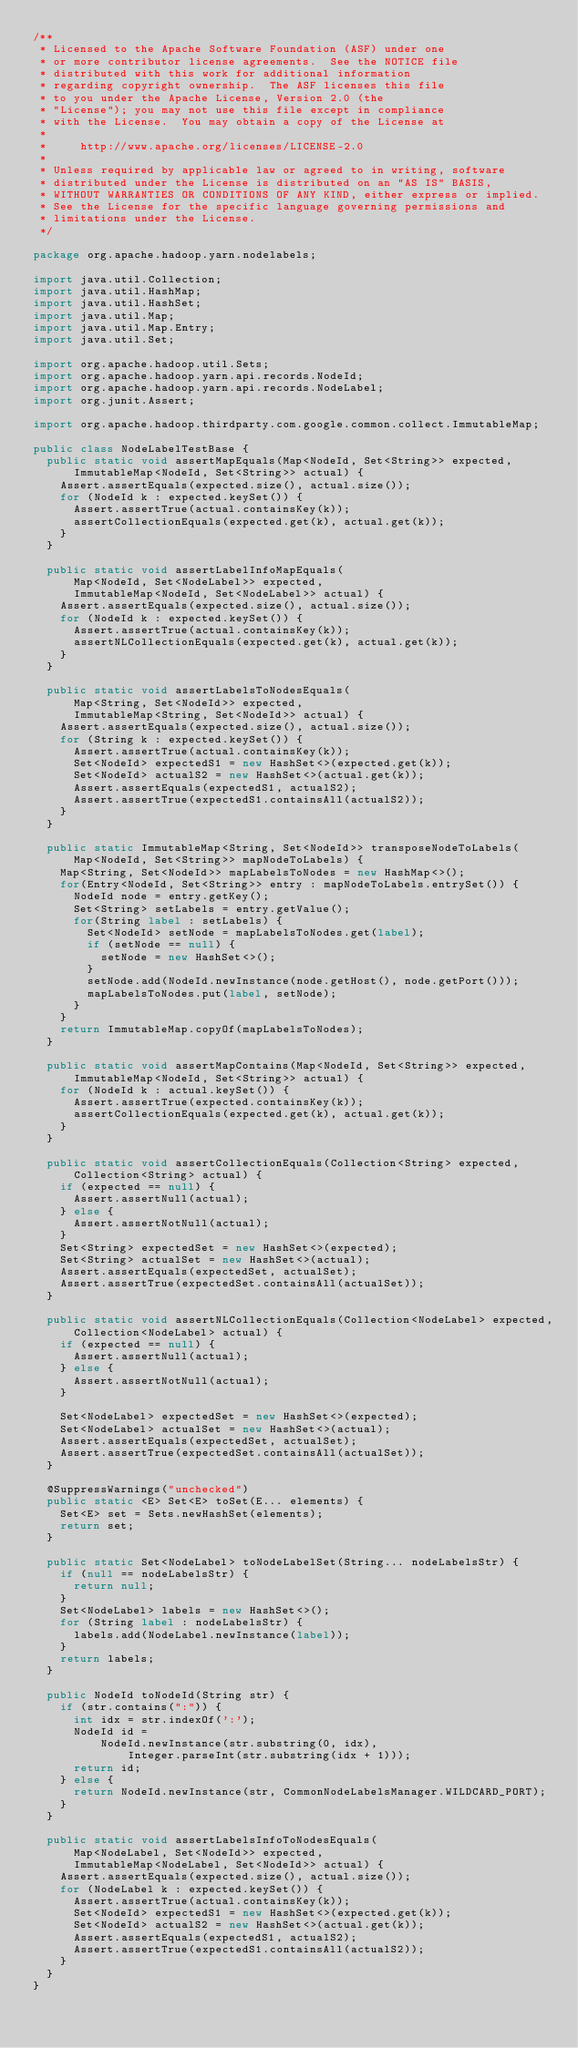Convert code to text. <code><loc_0><loc_0><loc_500><loc_500><_Java_>/**
 * Licensed to the Apache Software Foundation (ASF) under one
 * or more contributor license agreements.  See the NOTICE file
 * distributed with this work for additional information
 * regarding copyright ownership.  The ASF licenses this file
 * to you under the Apache License, Version 2.0 (the
 * "License"); you may not use this file except in compliance
 * with the License.  You may obtain a copy of the License at
 *
 *     http://www.apache.org/licenses/LICENSE-2.0
 *
 * Unless required by applicable law or agreed to in writing, software
 * distributed under the License is distributed on an "AS IS" BASIS,
 * WITHOUT WARRANTIES OR CONDITIONS OF ANY KIND, either express or implied.
 * See the License for the specific language governing permissions and
 * limitations under the License.
 */

package org.apache.hadoop.yarn.nodelabels;

import java.util.Collection;
import java.util.HashMap;
import java.util.HashSet;
import java.util.Map;
import java.util.Map.Entry;
import java.util.Set;

import org.apache.hadoop.util.Sets;
import org.apache.hadoop.yarn.api.records.NodeId;
import org.apache.hadoop.yarn.api.records.NodeLabel;
import org.junit.Assert;

import org.apache.hadoop.thirdparty.com.google.common.collect.ImmutableMap;

public class NodeLabelTestBase {
  public static void assertMapEquals(Map<NodeId, Set<String>> expected,
      ImmutableMap<NodeId, Set<String>> actual) {
    Assert.assertEquals(expected.size(), actual.size());
    for (NodeId k : expected.keySet()) {
      Assert.assertTrue(actual.containsKey(k));
      assertCollectionEquals(expected.get(k), actual.get(k));
    }
  }

  public static void assertLabelInfoMapEquals(
      Map<NodeId, Set<NodeLabel>> expected,
      ImmutableMap<NodeId, Set<NodeLabel>> actual) {
    Assert.assertEquals(expected.size(), actual.size());
    for (NodeId k : expected.keySet()) {
      Assert.assertTrue(actual.containsKey(k));
      assertNLCollectionEquals(expected.get(k), actual.get(k));
    }
  }

  public static void assertLabelsToNodesEquals(
      Map<String, Set<NodeId>> expected,
      ImmutableMap<String, Set<NodeId>> actual) {
    Assert.assertEquals(expected.size(), actual.size());
    for (String k : expected.keySet()) {
      Assert.assertTrue(actual.containsKey(k));
      Set<NodeId> expectedS1 = new HashSet<>(expected.get(k));
      Set<NodeId> actualS2 = new HashSet<>(actual.get(k));
      Assert.assertEquals(expectedS1, actualS2);
      Assert.assertTrue(expectedS1.containsAll(actualS2));
    }
  }

  public static ImmutableMap<String, Set<NodeId>> transposeNodeToLabels(
      Map<NodeId, Set<String>> mapNodeToLabels) {
    Map<String, Set<NodeId>> mapLabelsToNodes = new HashMap<>();
    for(Entry<NodeId, Set<String>> entry : mapNodeToLabels.entrySet()) {
      NodeId node = entry.getKey();
      Set<String> setLabels = entry.getValue();
      for(String label : setLabels) {
        Set<NodeId> setNode = mapLabelsToNodes.get(label);
        if (setNode == null) {
          setNode = new HashSet<>();
        }
        setNode.add(NodeId.newInstance(node.getHost(), node.getPort()));
        mapLabelsToNodes.put(label, setNode);
      }
    }
    return ImmutableMap.copyOf(mapLabelsToNodes);
  }

  public static void assertMapContains(Map<NodeId, Set<String>> expected,
      ImmutableMap<NodeId, Set<String>> actual) {
    for (NodeId k : actual.keySet()) {
      Assert.assertTrue(expected.containsKey(k));
      assertCollectionEquals(expected.get(k), actual.get(k));
    }
  }

  public static void assertCollectionEquals(Collection<String> expected,
      Collection<String> actual) {
    if (expected == null) {
      Assert.assertNull(actual);
    } else {
      Assert.assertNotNull(actual);
    }
    Set<String> expectedSet = new HashSet<>(expected);
    Set<String> actualSet = new HashSet<>(actual);
    Assert.assertEquals(expectedSet, actualSet);
    Assert.assertTrue(expectedSet.containsAll(actualSet));
  }

  public static void assertNLCollectionEquals(Collection<NodeLabel> expected,
      Collection<NodeLabel> actual) {
    if (expected == null) {
      Assert.assertNull(actual);
    } else {
      Assert.assertNotNull(actual);
    }

    Set<NodeLabel> expectedSet = new HashSet<>(expected);
    Set<NodeLabel> actualSet = new HashSet<>(actual);
    Assert.assertEquals(expectedSet, actualSet);
    Assert.assertTrue(expectedSet.containsAll(actualSet));
  }

  @SuppressWarnings("unchecked")
  public static <E> Set<E> toSet(E... elements) {
    Set<E> set = Sets.newHashSet(elements);
    return set;
  }
  
  public static Set<NodeLabel> toNodeLabelSet(String... nodeLabelsStr) {
    if (null == nodeLabelsStr) {
      return null;
    }
    Set<NodeLabel> labels = new HashSet<>();
    for (String label : nodeLabelsStr) {
      labels.add(NodeLabel.newInstance(label));
    }
    return labels;
  }

  public NodeId toNodeId(String str) {
    if (str.contains(":")) {
      int idx = str.indexOf(':');
      NodeId id =
          NodeId.newInstance(str.substring(0, idx),
              Integer.parseInt(str.substring(idx + 1)));
      return id;
    } else {
      return NodeId.newInstance(str, CommonNodeLabelsManager.WILDCARD_PORT);
    }
  }

  public static void assertLabelsInfoToNodesEquals(
      Map<NodeLabel, Set<NodeId>> expected,
      ImmutableMap<NodeLabel, Set<NodeId>> actual) {
    Assert.assertEquals(expected.size(), actual.size());
    for (NodeLabel k : expected.keySet()) {
      Assert.assertTrue(actual.containsKey(k));
      Set<NodeId> expectedS1 = new HashSet<>(expected.get(k));
      Set<NodeId> actualS2 = new HashSet<>(actual.get(k));
      Assert.assertEquals(expectedS1, actualS2);
      Assert.assertTrue(expectedS1.containsAll(actualS2));
    }
  }
}
</code> 